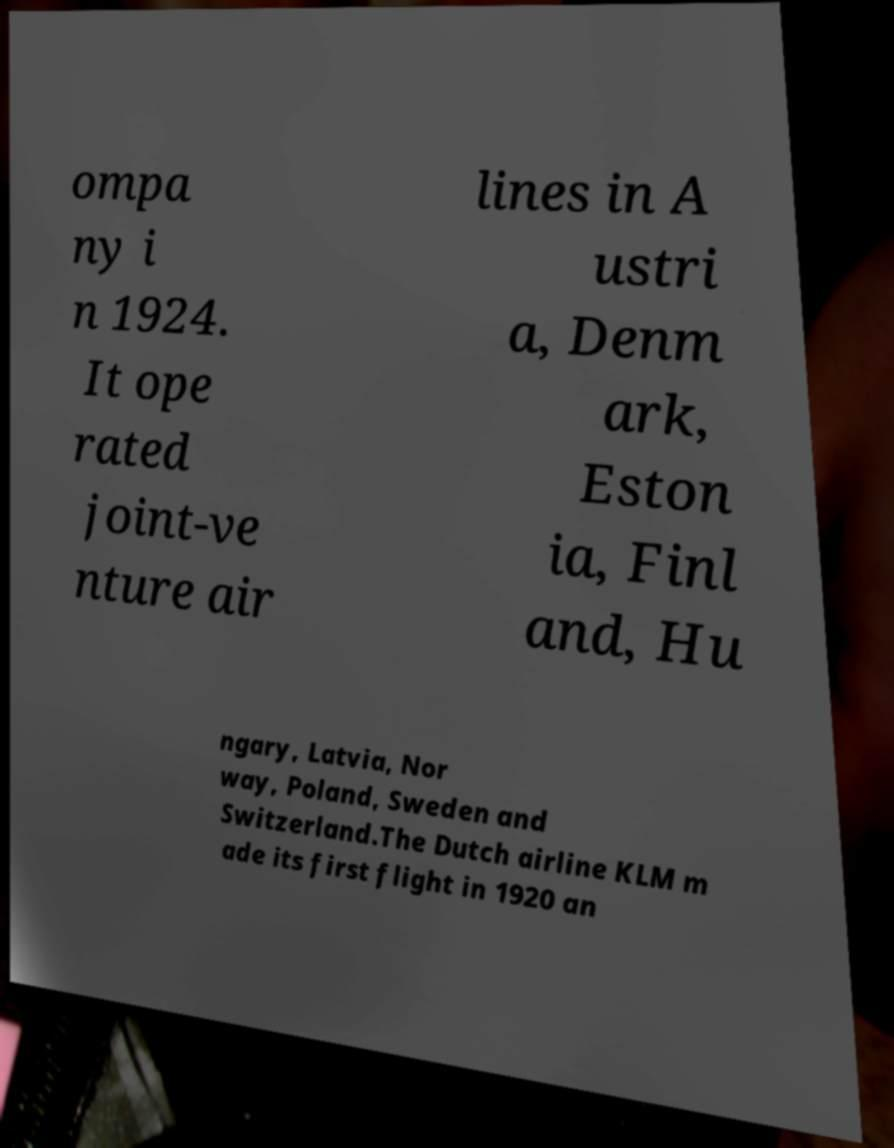Please read and relay the text visible in this image. What does it say? ompa ny i n 1924. It ope rated joint-ve nture air lines in A ustri a, Denm ark, Eston ia, Finl and, Hu ngary, Latvia, Nor way, Poland, Sweden and Switzerland.The Dutch airline KLM m ade its first flight in 1920 an 